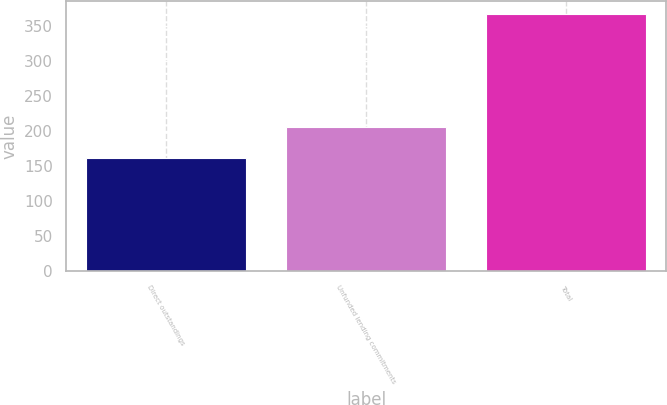<chart> <loc_0><loc_0><loc_500><loc_500><bar_chart><fcel>Direct outstandings<fcel>Unfunded lending commitments<fcel>Total<nl><fcel>161<fcel>206<fcel>367<nl></chart> 